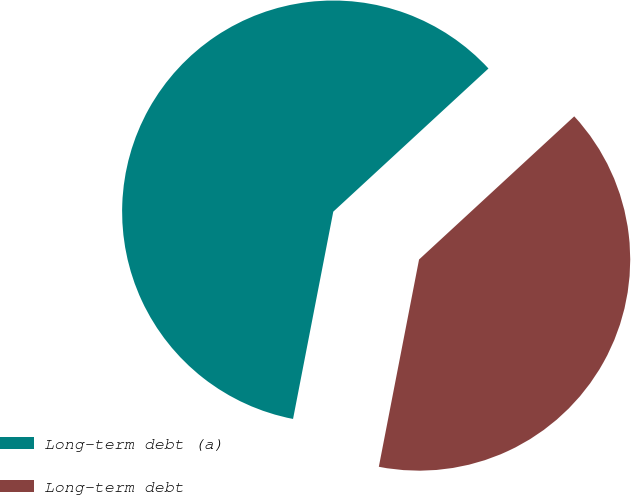Convert chart. <chart><loc_0><loc_0><loc_500><loc_500><pie_chart><fcel>Long-term debt (a)<fcel>Long-term debt<nl><fcel>60.09%<fcel>39.91%<nl></chart> 